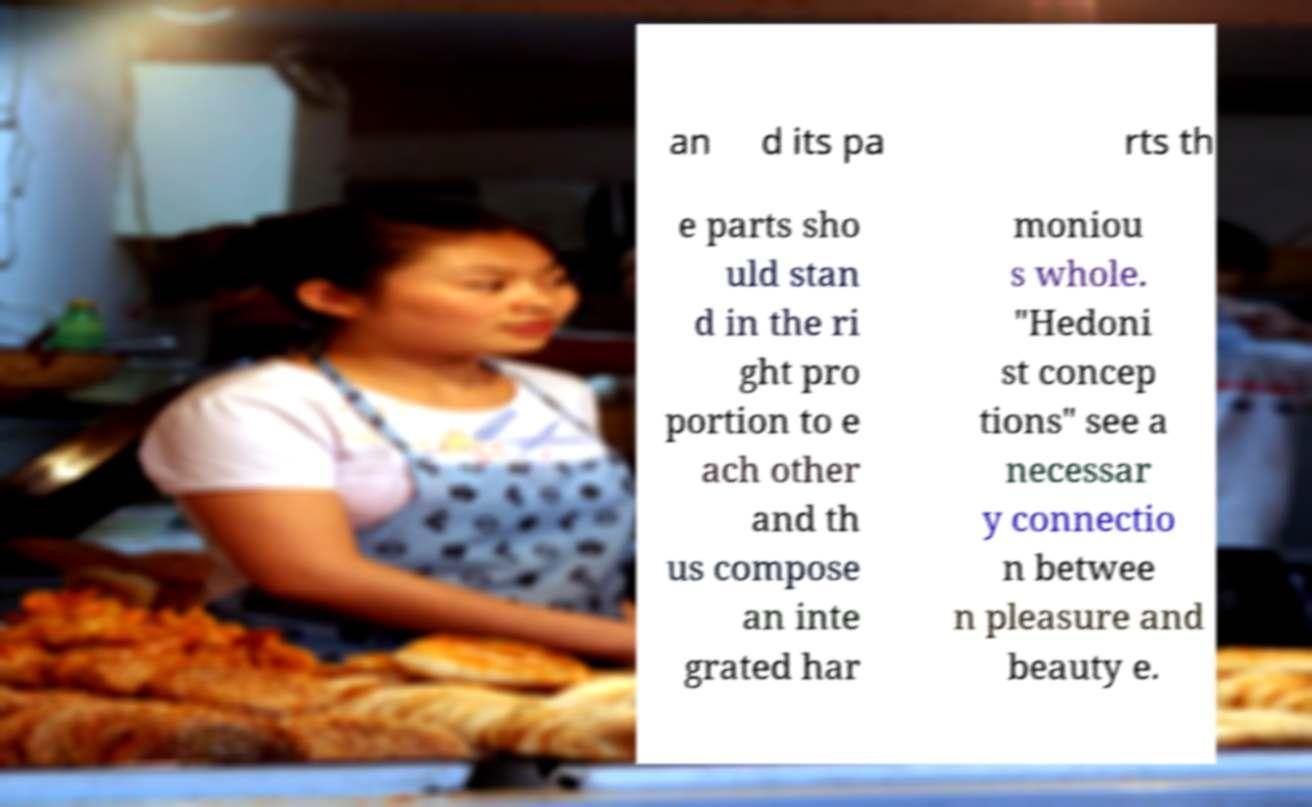Could you assist in decoding the text presented in this image and type it out clearly? an d its pa rts th e parts sho uld stan d in the ri ght pro portion to e ach other and th us compose an inte grated har moniou s whole. "Hedoni st concep tions" see a necessar y connectio n betwee n pleasure and beauty e. 